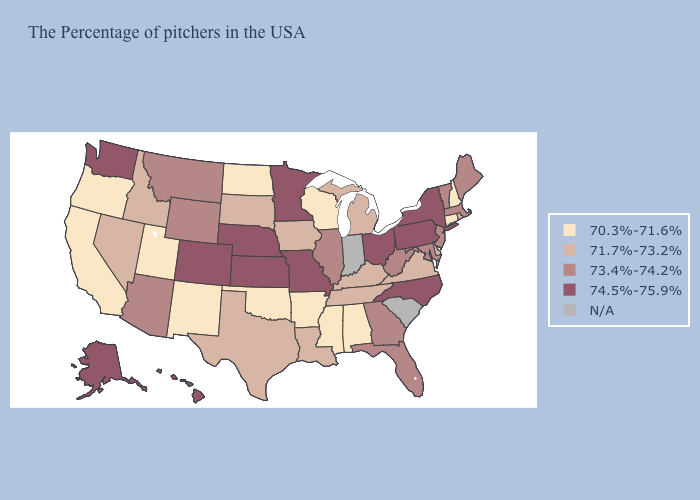Does the first symbol in the legend represent the smallest category?
Concise answer only. Yes. Among the states that border Michigan , does Wisconsin have the lowest value?
Keep it brief. Yes. What is the highest value in the Northeast ?
Be succinct. 74.5%-75.9%. What is the value of Kansas?
Quick response, please. 74.5%-75.9%. How many symbols are there in the legend?
Answer briefly. 5. What is the value of Minnesota?
Short answer required. 74.5%-75.9%. Among the states that border Missouri , does Arkansas have the lowest value?
Keep it brief. Yes. Among the states that border Pennsylvania , does Maryland have the lowest value?
Concise answer only. No. What is the value of Montana?
Short answer required. 73.4%-74.2%. Is the legend a continuous bar?
Be succinct. No. Does North Dakota have the lowest value in the MidWest?
Be succinct. Yes. Name the states that have a value in the range 73.4%-74.2%?
Be succinct. Maine, Massachusetts, Vermont, New Jersey, Maryland, West Virginia, Florida, Georgia, Illinois, Wyoming, Montana, Arizona. Does North Dakota have the lowest value in the MidWest?
Write a very short answer. Yes. Does Wisconsin have the lowest value in the MidWest?
Keep it brief. Yes. 